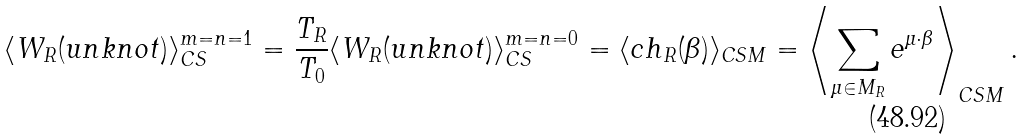<formula> <loc_0><loc_0><loc_500><loc_500>\langle W _ { R } ( u n k n o t ) \rangle _ { C S } ^ { m = n = 1 } = \frac { T _ { R } } { T _ { 0 } } \langle W _ { R } ( u n k n o t ) \rangle _ { C S } ^ { m = n = 0 } = \langle c h _ { R } ( \beta ) \rangle _ { C S M } = \left \langle \sum _ { \mu \in M _ { R } } e ^ { \mu \cdot \beta } \right \rangle _ { C S M } .</formula> 